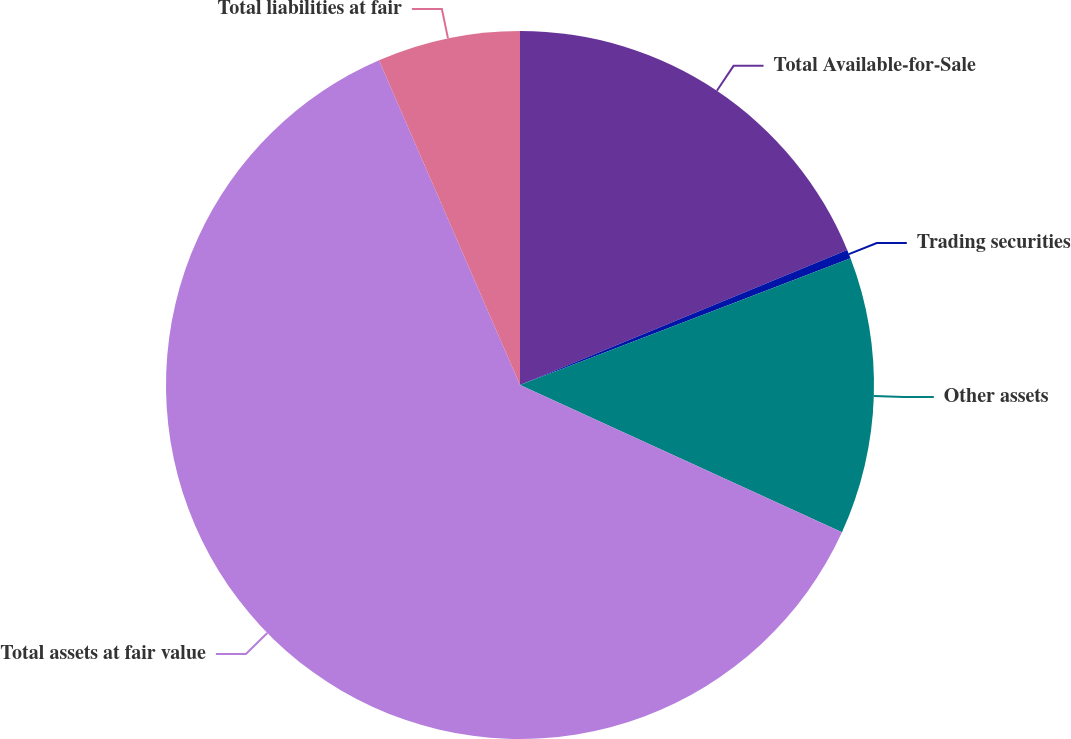Convert chart. <chart><loc_0><loc_0><loc_500><loc_500><pie_chart><fcel>Total Available-for-Sale<fcel>Trading securities<fcel>Other assets<fcel>Total assets at fair value<fcel>Total liabilities at fair<nl><fcel>18.77%<fcel>0.4%<fcel>12.65%<fcel>61.65%<fcel>6.52%<nl></chart> 